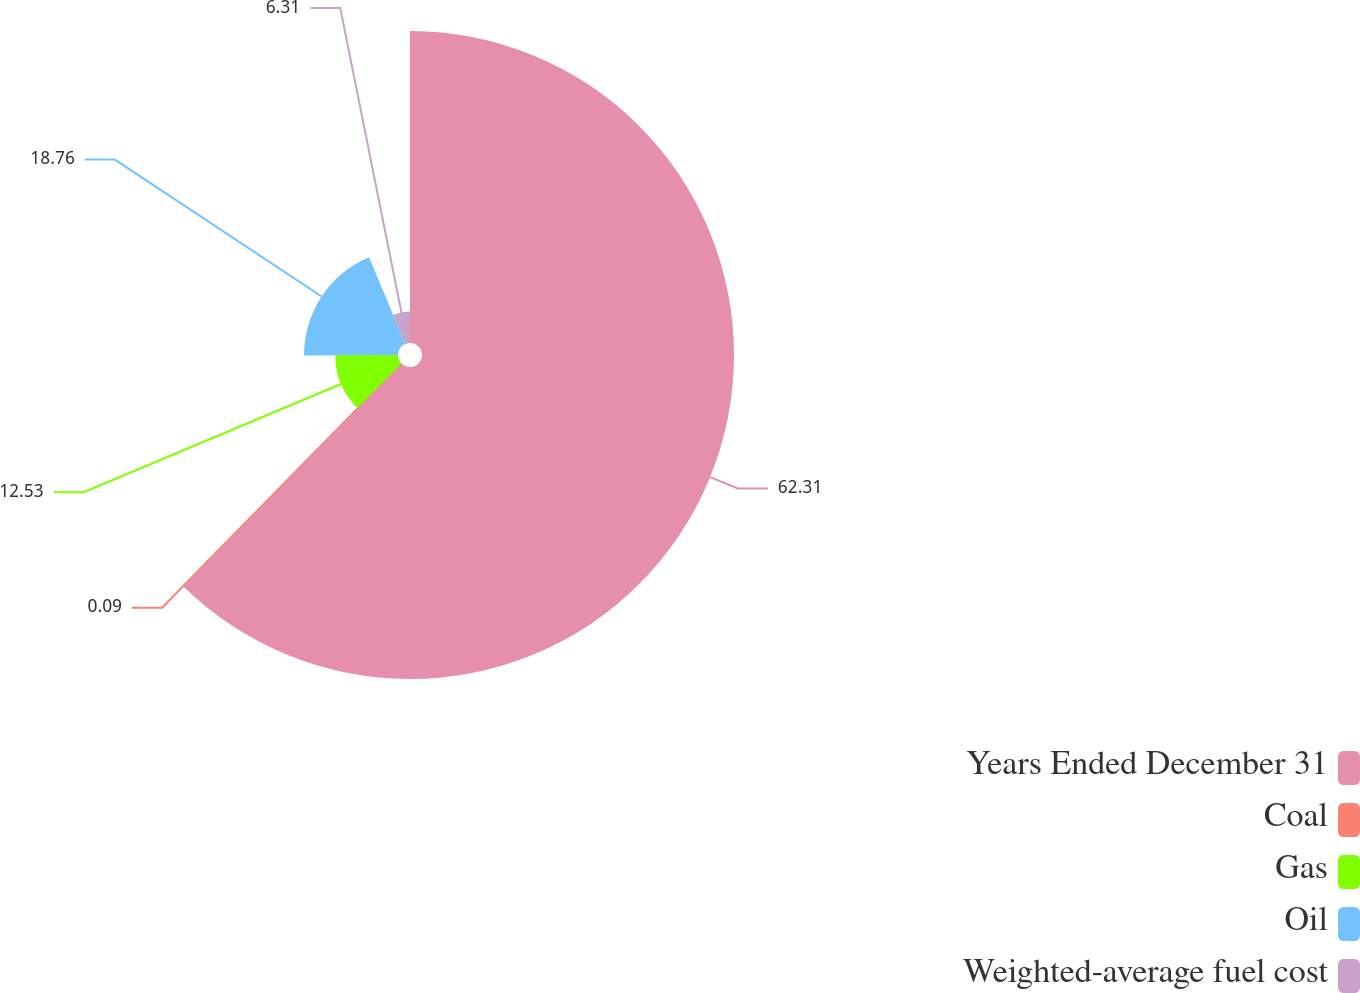<chart> <loc_0><loc_0><loc_500><loc_500><pie_chart><fcel>Years Ended December 31<fcel>Coal<fcel>Gas<fcel>Oil<fcel>Weighted-average fuel cost<nl><fcel>62.3%<fcel>0.09%<fcel>12.53%<fcel>18.76%<fcel>6.31%<nl></chart> 